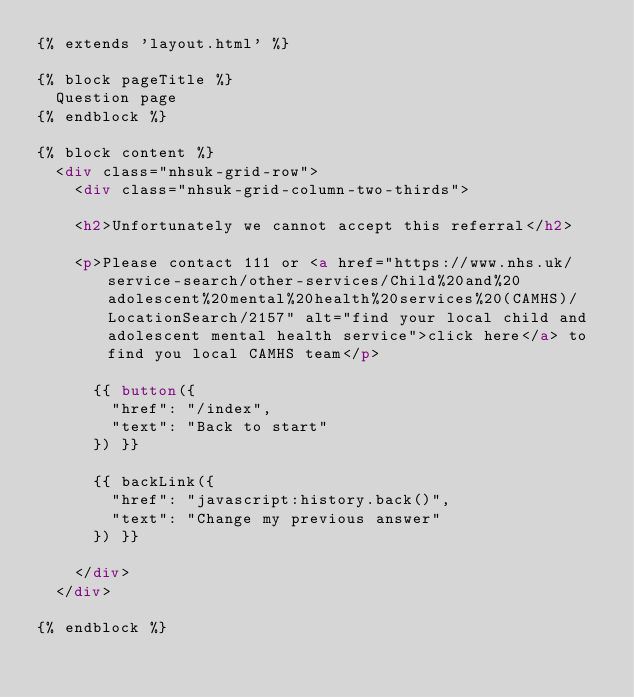Convert code to text. <code><loc_0><loc_0><loc_500><loc_500><_HTML_>{% extends 'layout.html' %}

{% block pageTitle %}
  Question page
{% endblock %}

{% block content %}
  <div class="nhsuk-grid-row">
    <div class="nhsuk-grid-column-two-thirds">

    <h2>Unfortunately we cannot accept this referral</h2> 

    <p>Please contact 111 or <a href="https://www.nhs.uk/service-search/other-services/Child%20and%20adolescent%20mental%20health%20services%20(CAMHS)/LocationSearch/2157" alt="find your local child and adolescent mental health service">click here</a> to find you local CAMHS team</p>

      {{ button({
        "href": "/index",
        "text": "Back to start"
      }) }}

      {{ backLink({
        "href": "javascript:history.back()",
        "text": "Change my previous answer"
      }) }}

    </div>
  </div>

{% endblock %}
</code> 